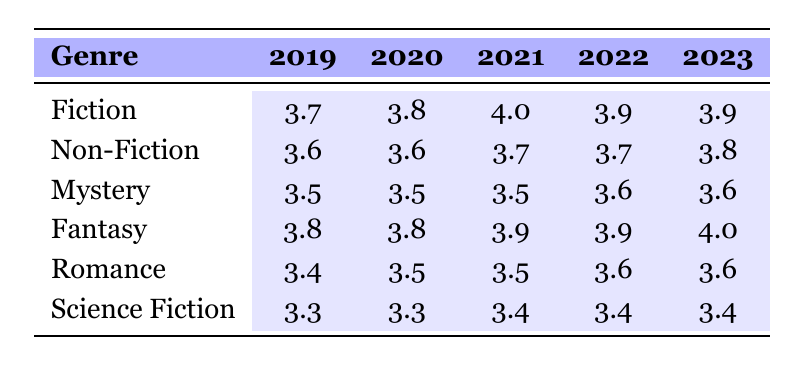What was the log sales figure for the Fiction genre in 2021? The log sales figure for Fiction in 2021 is displayed directly in the table under that genre and year, which is 4.0
Answer: 4.0 Which genre had the highest log sales in 2023? Looking at the log sales in 2023, Fiction has 3.9, Non-Fiction has 3.8, Mystery has 3.6, Fantasy has 4.0, Romance has 3.6, and Science Fiction has 3.4. The highest is Fantasy with 4.0
Answer: Fantasy What is the total sales for Non-Fiction from 2019 to 2023? The total sales for Non-Fiction can be calculated by summing the sales figures: 4000 + 4500 + 5000 + 5500 + 6000 = 25000
Answer: 25000 Did Romance see an increase in log sales from 2019 to 2023? In 2019, Romance had a log sales figure of 3.4 and in 2023 it is 3.6. Since 3.6 is greater than 3.4, this indicates an increase
Answer: Yes Which genre had the lowest average log sales over the five years? To find the lowest average, calculate the average for each genre: Fiction (3.84), Non-Fiction (3.68), Mystery (3.54), Fantasy (3.92), Romance (3.52), Science Fiction (3.36). The lowest average is for Science Fiction at 3.36
Answer: Science Fiction What is the difference in log sales between Fiction and Fantasy in 2022? For 2022, Fiction had log sales of 3.9 and Fantasy also 3.9, so the difference is 3.9 - 3.9 = 0
Answer: 0 Which genre had consistent log sales over the years compared to others? Comparing the years for each genre, Mystery had a constant log sales figure of 3.5 from 2019 to 2021 and then a small increase to 3.6 in the following years. This shows it was consistent for most of the time
Answer: Mystery What trend can be inferred about the log sales of the Science Fiction genre from 2019 to 2023? Reviewing the log sales from 2019 to 2023, Science Fiction started at 3.3 and remained the same until 2022, only showing a slight increase to 3.4 in 2021. This indicates a stagnation trend with minimal growth
Answer: Stagnation with minimal growth 